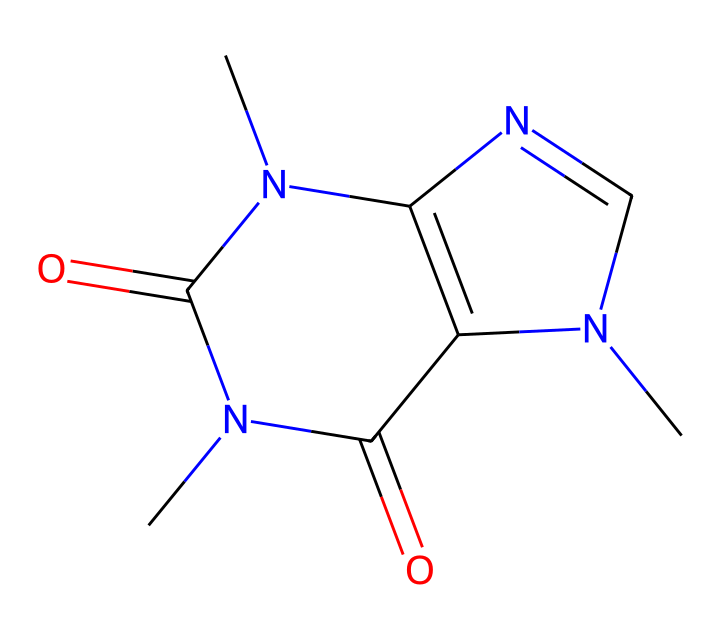What is the molecular formula of caffeine based on the SMILES? To determine the molecular formula from the SMILES notation, identify the type and count of atoms. The SMILES shows carbon (C), nitrogen (N), and oxygen (O) atoms. Counting, we see 8 carbon atoms, 10 hydrogen atoms, 4 nitrogen atoms, and 2 oxygen atoms, which yields the molecular formula C8H10N4O2.
Answer: C8H10N4O2 How many nitrogen atoms are present in this structure? By examining the SMILES, we can locate the nitrogen (N) symbols. There are four instances of nitrogen in the molecular structure, thus the count of nitrogen atoms is four.
Answer: 4 What type of compound is caffeine classified as? Caffeine has a complex structure that includes multiple nitrogen atoms and is known for its psychoactive effects. Considering these characteristics, caffeine is classified as an alkaloid.
Answer: alkaloid How many rings are in the chemical structure of caffeine? Upon inspecting the structure represented in the SMILES, we can see two fused ring structures. Each ring is indicative of the complexity of the caffeine molecule. Thus, there are two rings.
Answer: 2 What kind of bonding primarily exists in caffeine? In assessing the structure from the SMILES, we observe single (sigma) bonds as well as some double bonds (pi) within the rings. Since caffeine is a non-electrolyte and has stable covalent bonds, the primary type of bonding present is covalent bonding.
Answer: covalent Which groups in caffeine suggest its aromatic character? The fused ring system in caffeine contains alternating double bonds between carbon atoms, which indicates delocalization of electrons. This delocalization gives rise to the aromatic character typically associated with compounds like caffeine. Therefore, the aromatic character is suggested by the presence of these double bonds in a cyclic structure.
Answer: aromatic Does caffeine behave as an electrolyte or a non-electrolyte? Given that caffeine, when dissolved in water, does not dissociate into ions, it functions as a non-electrolyte. Thus, it does not conduct electricity in solution.
Answer: non-electrolyte 